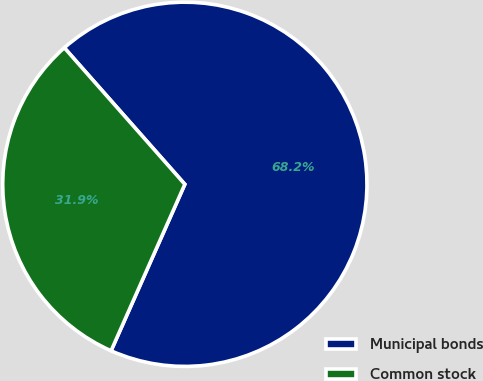Convert chart. <chart><loc_0><loc_0><loc_500><loc_500><pie_chart><fcel>Municipal bonds<fcel>Common stock<nl><fcel>68.15%<fcel>31.85%<nl></chart> 